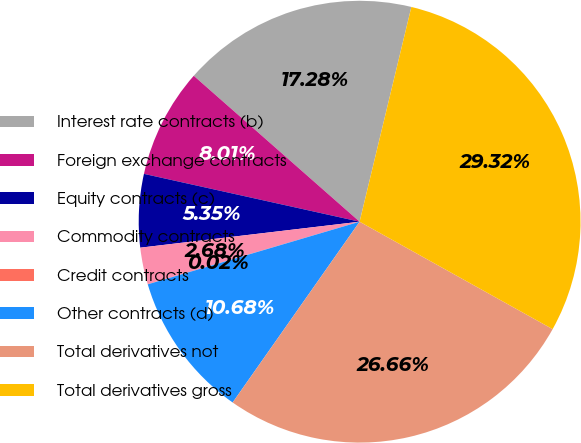Convert chart. <chart><loc_0><loc_0><loc_500><loc_500><pie_chart><fcel>Interest rate contracts (b)<fcel>Foreign exchange contracts<fcel>Equity contracts (c)<fcel>Commodity contracts<fcel>Credit contracts<fcel>Other contracts (d)<fcel>Total derivatives not<fcel>Total derivatives gross<nl><fcel>17.28%<fcel>8.01%<fcel>5.35%<fcel>2.68%<fcel>0.02%<fcel>10.68%<fcel>26.66%<fcel>29.32%<nl></chart> 